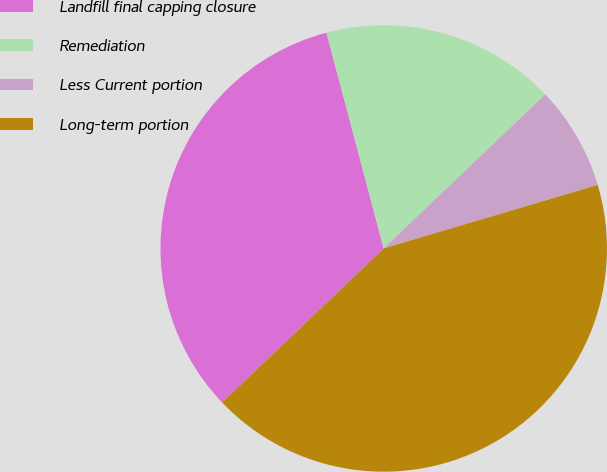Convert chart to OTSL. <chart><loc_0><loc_0><loc_500><loc_500><pie_chart><fcel>Landfill final capping closure<fcel>Remediation<fcel>Less Current portion<fcel>Long-term portion<nl><fcel>32.99%<fcel>17.01%<fcel>7.53%<fcel>42.47%<nl></chart> 